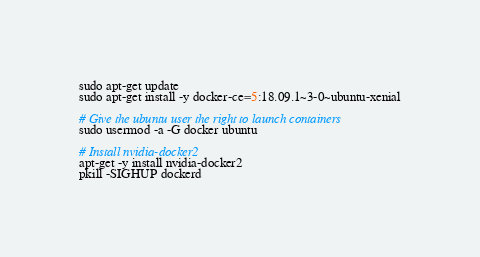Convert code to text. <code><loc_0><loc_0><loc_500><loc_500><_Bash_>sudo apt-get update
sudo apt-get install -y docker-ce=5:18.09.1~3-0~ubuntu-xenial

# Give the ubuntu user the right to launch containers
sudo usermod -a -G docker ubuntu

# Install nvidia-docker2
apt-get -y install nvidia-docker2
pkill -SIGHUP dockerd
</code> 